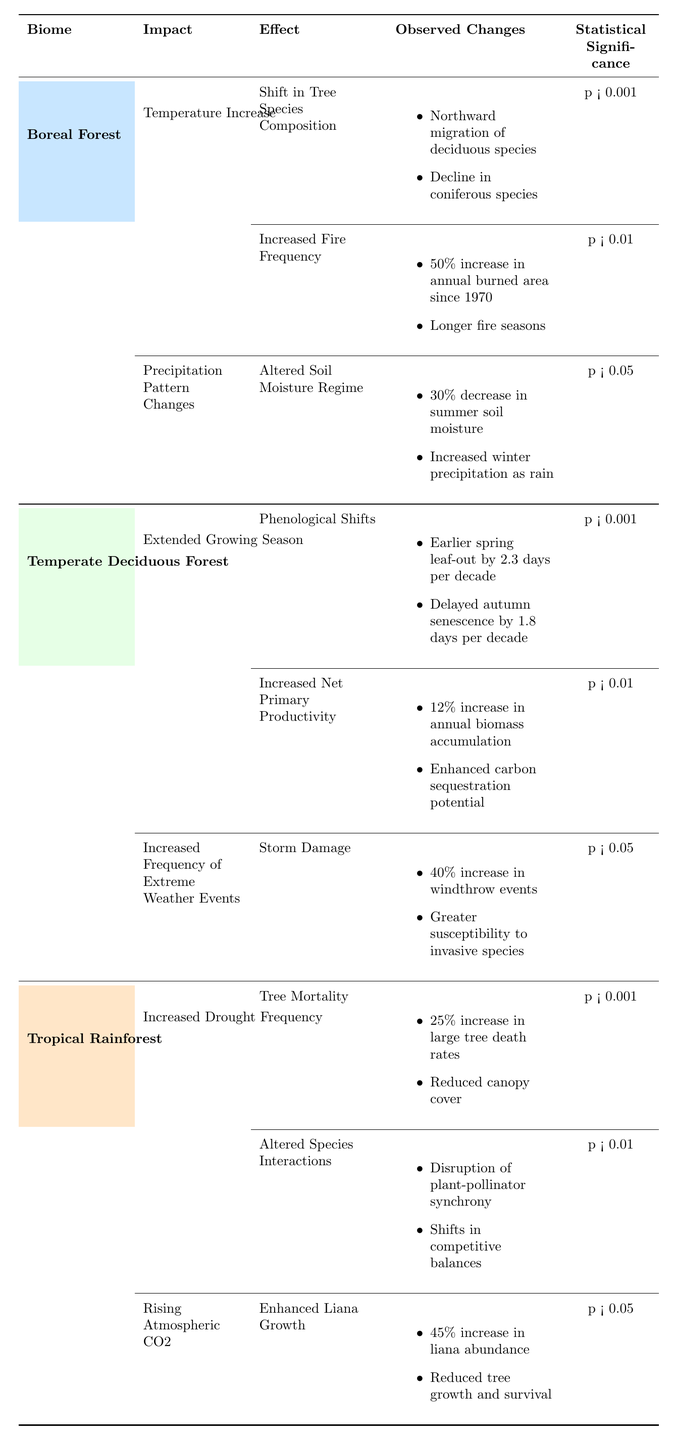What is the statistical significance of the "Increased Fire Frequency" effect in the Boreal Forest? The table indicates that the statistical significance for "Increased Fire Frequency" is denoted as "p < 0.01." Therefore, it shows a significant effect at the 1% level.
Answer: p < 0.01 How many effects are associated with "Temperature Increase" in the Boreal Forest? There are two effects listed under "Temperature Increase": "Shift in Tree Species Composition" and "Increased Fire Frequency." Therefore, the count is 2.
Answer: 2 Is there any observed change regarding "Altered Soil Moisture Regime" in the Boreal Forest? The table shows that under "Altered Soil Moisture Regime," there are two observed changes: a 30% decrease in summer soil moisture and increased winter precipitation as rain, confirming it is true.
Answer: Yes How does the statistical significance of "Tree Mortality" in the Tropical Rainforest compare to "Altered Soil Moisture Regime" in the Boreal Forest? The statistical significance of "Tree Mortality" is "p < 0.001," while that of "Altered Soil Moisture Regime" is "p < 0.05." Since "p < 0.001" is more significant than "p < 0.05," it indicates a stronger effect in "Tree Mortality" compared to "Altered Soil Moisture Regime."
Answer: More significant What is the overall impact of climate change observed in the Temperate Deciduous Forest regarding extreme weather events? The Temperate Deciduous Forest shows increased frequency of extreme weather events, specifically indicated by "Storm Damage," which includes a 40% increase in windthrow events and greater susceptibility to invasive species.
Answer: Increased frequency of storm damage Calculate the difference in statistical significance between "Phenological Shifts" in the Temperate Deciduous Forest and "Enhanced Liana Growth" in the Tropical Rainforest. "Phenological Shifts" has a statistical significance of "p < 0.001," while "Enhanced Liana Growth" has "p < 0.05." To determine the difference, we assess that one is significant at the 0.1% level and the other at 5%, indicating a larger degree of significance for "Phenological Shifts."
Answer: p < 0.001 is more significant Which biome has the highest number of effects associated with climate change impacts, and how many are there? Upon reviewing the table, the Boreal Forest has three effects under two impacts (one impact has two effects, the other has one), while the Temperate Deciduous Forest also has three effects under two impacts, and the Tropical Rainforest has three effects under two impacts as well. Therefore, all biomes have equal effects.
Answer: All biomes have 3 effects What are the observed changes related to "Enhanced Net Primary Productivity" in the Temperate Deciduous Forest? The table lists two observed changes under "Increased Net Primary Productivity": a 12% increase in annual biomass accumulation and enhanced carbon sequestration potential.
Answer: 12% increase in biomass, enhanced carbon sequestration Identify if there are differences in impacts related to atmospheric changes in "Rising Atmospheric CO2" for the Tropical Rainforest. The identified impact related to atmospheric changes for "Rising Atmospheric CO2" indicates "Enhanced Liana Growth" with specific observed changes. Since this is a listed impact under climate change, it confirms differences exist compared to other biomes not showing similar impacts.
Answer: Yes, differences exist What is the significance level of "Delayed autumn senescence"? "Delayed autumn senescence" is part of "Phenological Shifts" in the Temperate Deciduous Forest, which has a statistical significance of "p < 0.001."
Answer: p < 0.001 